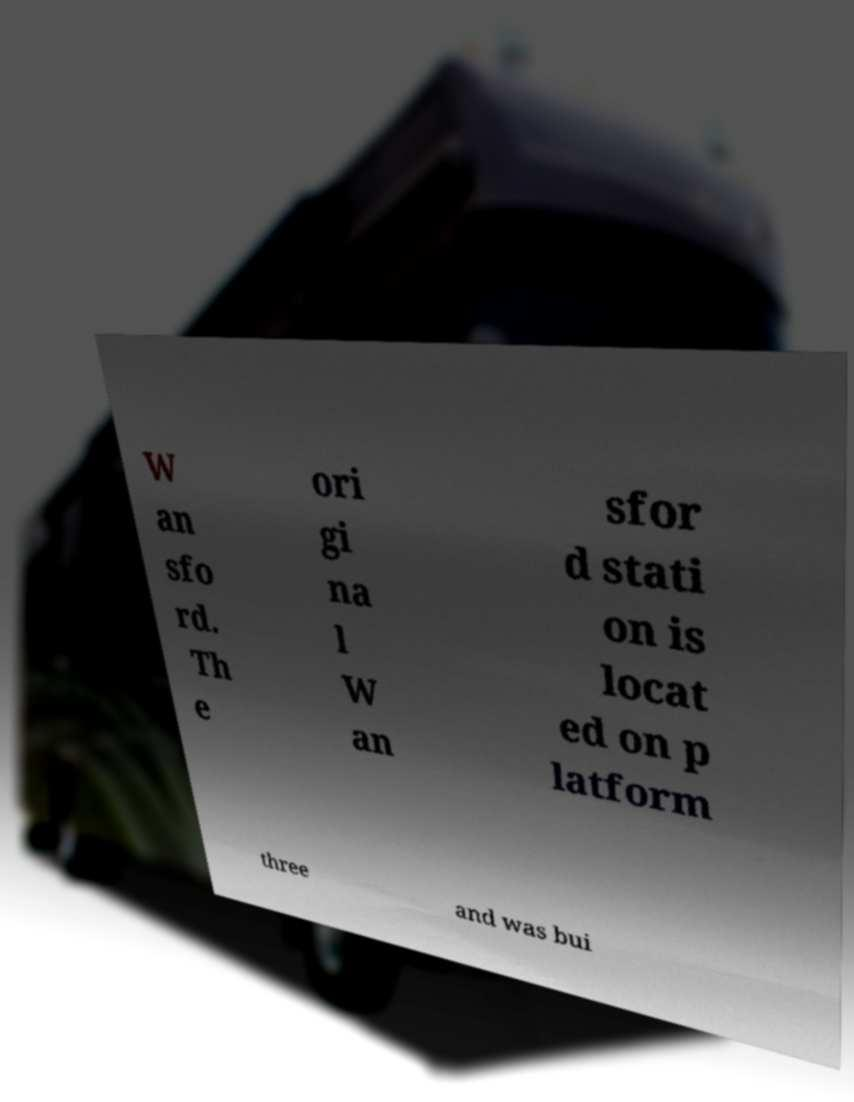Please identify and transcribe the text found in this image. W an sfo rd. Th e ori gi na l W an sfor d stati on is locat ed on p latform three and was bui 